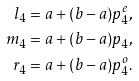Convert formula to latex. <formula><loc_0><loc_0><loc_500><loc_500>l _ { 4 } & = a + ( b - a ) p _ { 4 } ^ { e } , \\ m _ { 4 } & = a + ( b - a ) p _ { 4 } , \\ r _ { 4 } & = a + ( b - a ) p _ { 4 } ^ { o } .</formula> 